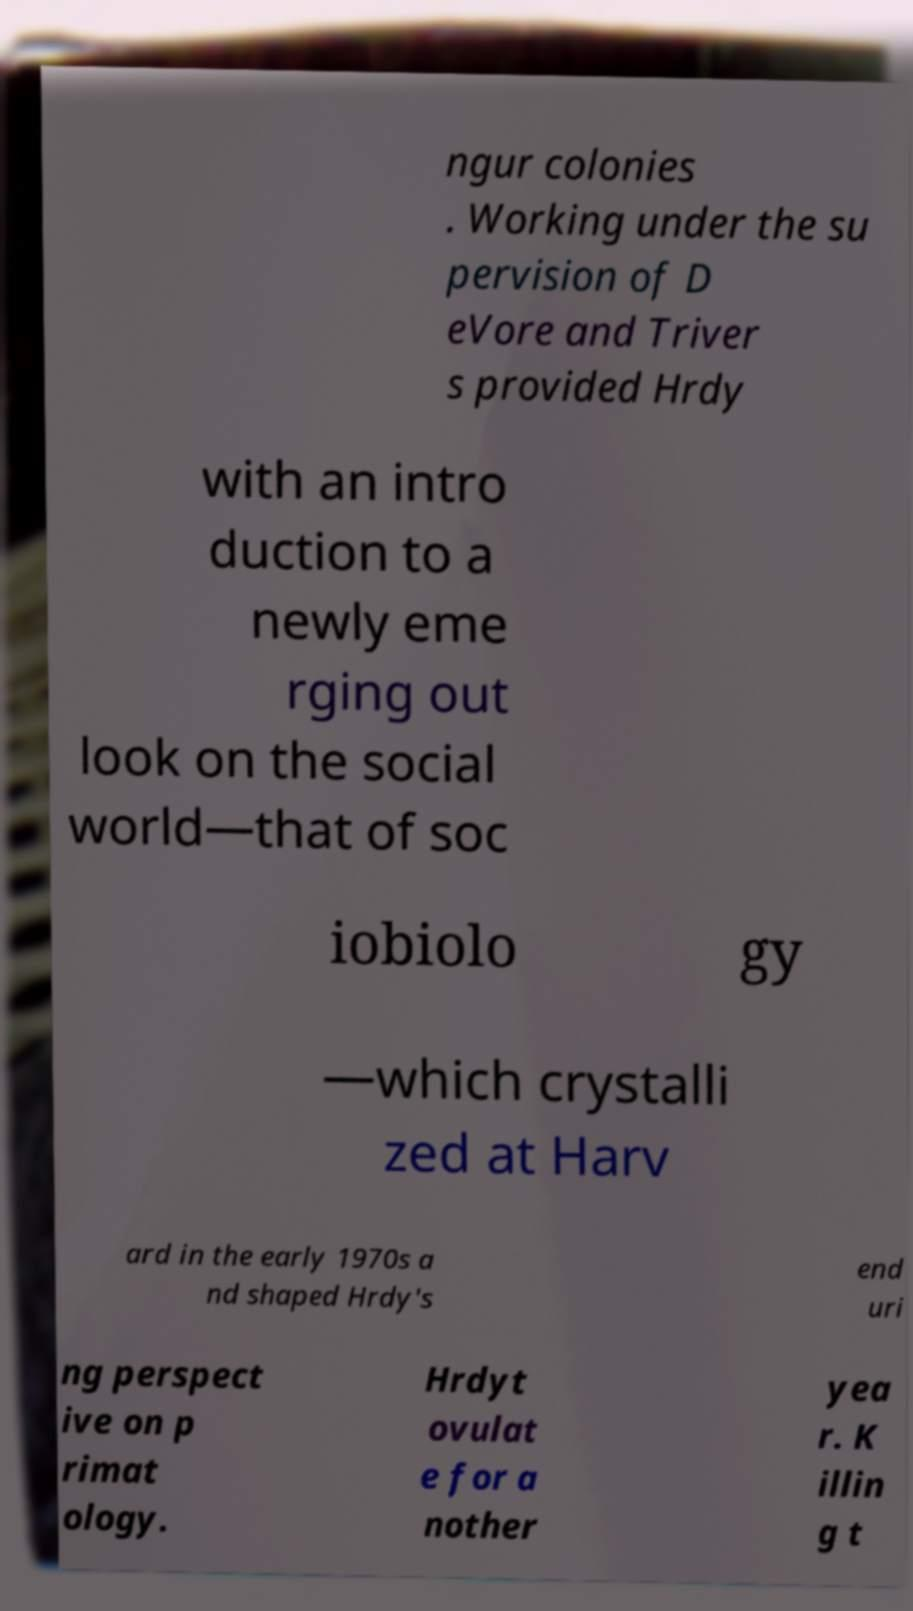Can you read and provide the text displayed in the image?This photo seems to have some interesting text. Can you extract and type it out for me? ngur colonies . Working under the su pervision of D eVore and Triver s provided Hrdy with an intro duction to a newly eme rging out look on the social world—that of soc iobiolo gy —which crystalli zed at Harv ard in the early 1970s a nd shaped Hrdy's end uri ng perspect ive on p rimat ology. Hrdyt ovulat e for a nother yea r. K illin g t 